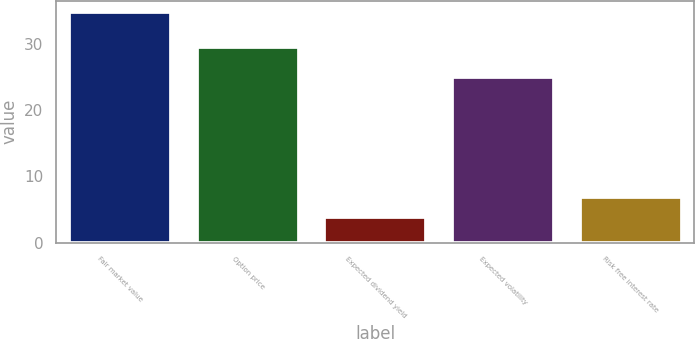<chart> <loc_0><loc_0><loc_500><loc_500><bar_chart><fcel>Fair market value<fcel>Option price<fcel>Expected dividend yield<fcel>Expected volatility<fcel>Risk free interest rate<nl><fcel>34.79<fcel>29.57<fcel>3.84<fcel>25<fcel>6.94<nl></chart> 